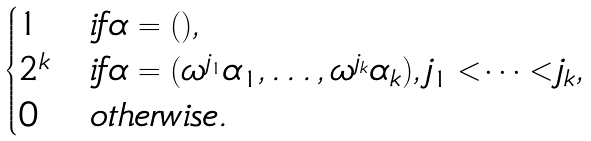Convert formula to latex. <formula><loc_0><loc_0><loc_500><loc_500>\begin{cases} 1 & i f \alpha = ( ) , \\ 2 ^ { k } & i f \alpha = ( \omega ^ { j _ { 1 } } \alpha _ { 1 } , \dots , \omega ^ { j _ { k } } \alpha _ { k } ) , j _ { 1 } < \cdots < j _ { k } , \\ 0 & o t h e r w i s e . \end{cases}</formula> 